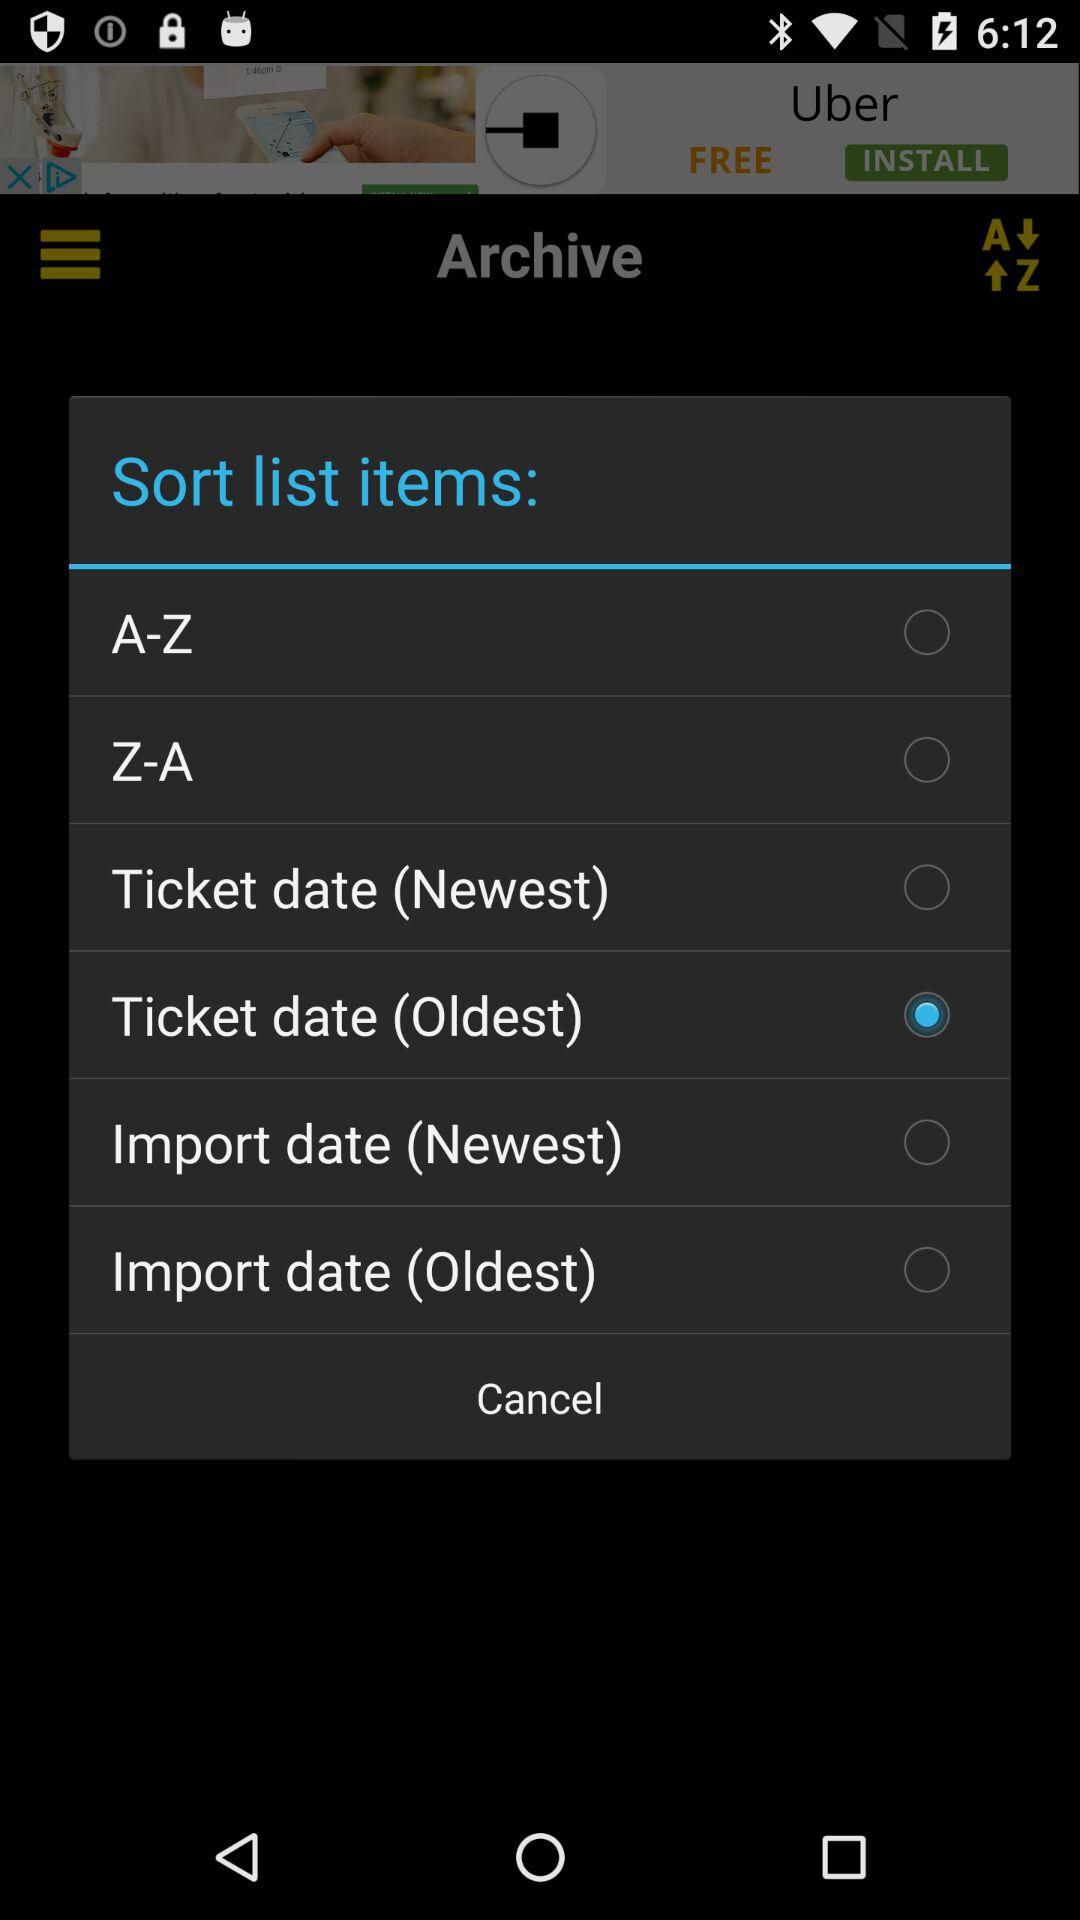Which option is selected in the "Sort list items"? The selected option is "Ticket date (Oldest)". 